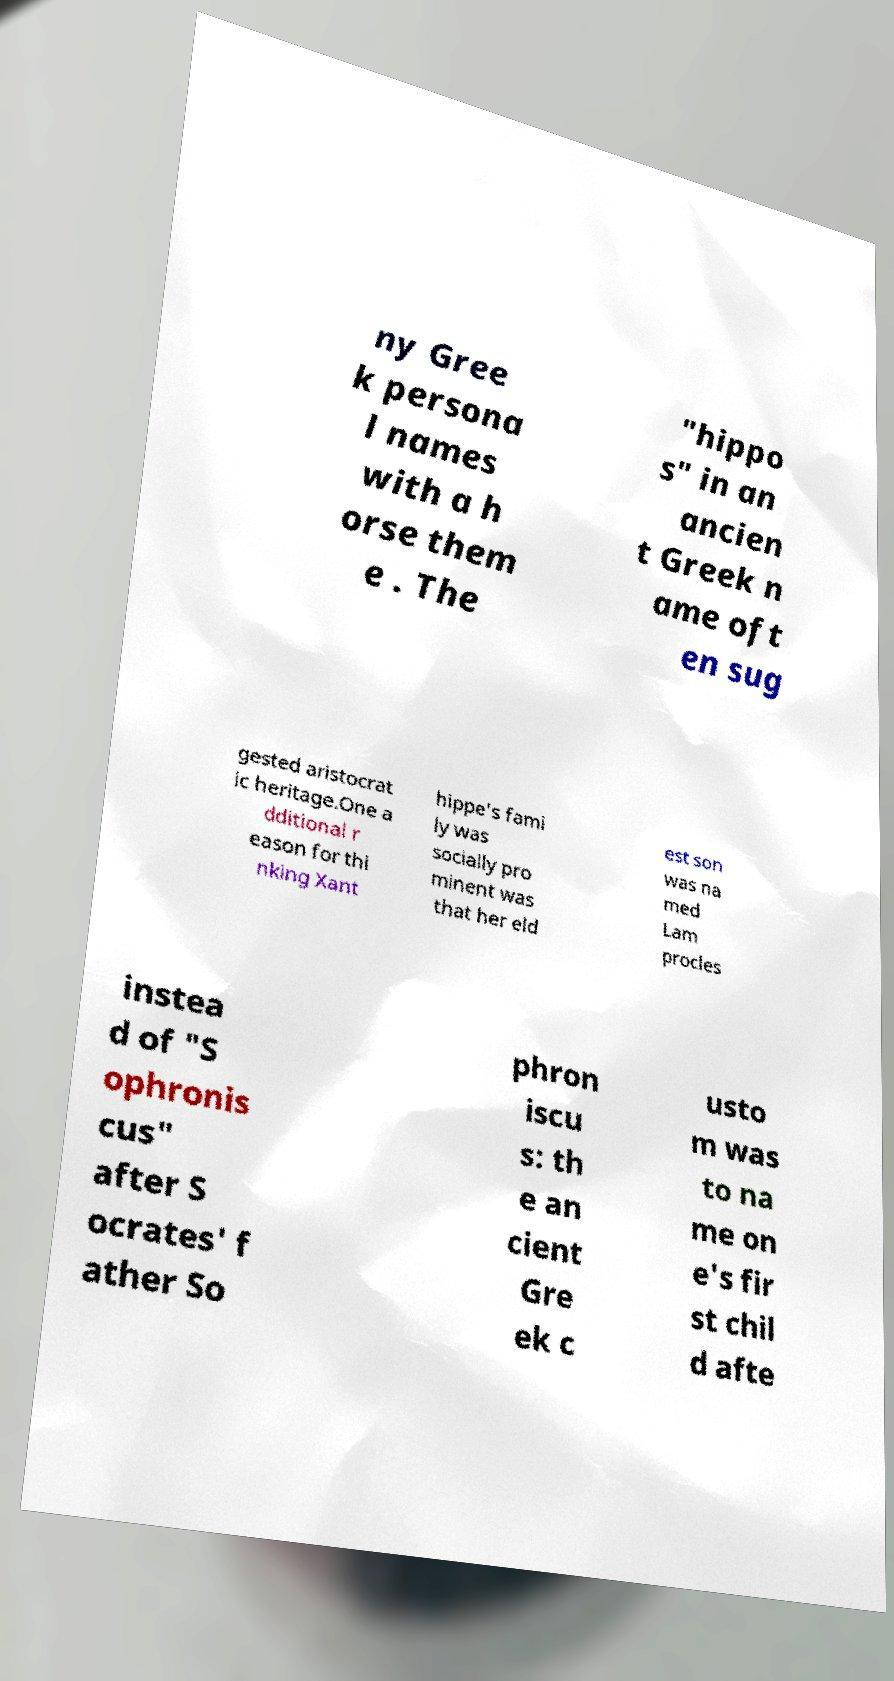For documentation purposes, I need the text within this image transcribed. Could you provide that? ny Gree k persona l names with a h orse them e . The "hippo s" in an ancien t Greek n ame oft en sug gested aristocrat ic heritage.One a dditional r eason for thi nking Xant hippe's fami ly was socially pro minent was that her eld est son was na med Lam procles instea d of "S ophronis cus" after S ocrates' f ather So phron iscu s: th e an cient Gre ek c usto m was to na me on e's fir st chil d afte 